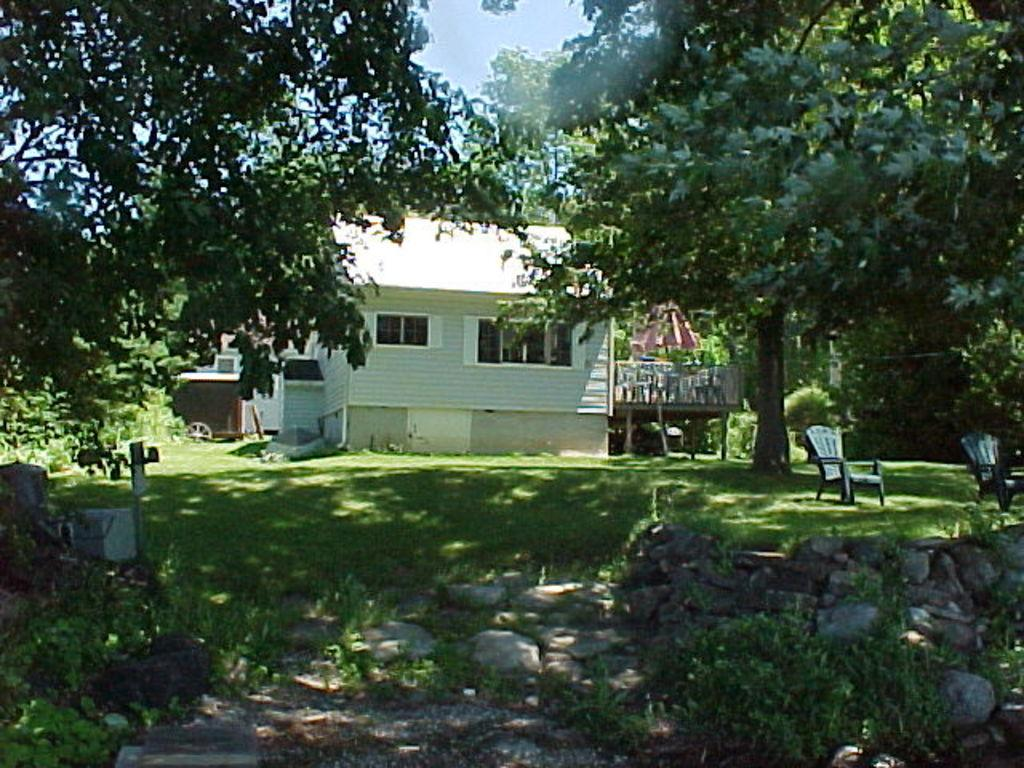What type of surface is visible in the image? There is a grass surface in the image. What type of vegetation is present in the image? There are trees in the image. What type of furniture is visible in the image? There are chairs in the image. What type of structure is present in the image? There is a house in the image. What is visible in the background of the image? The sky is visible in the image. What time of day is it in the image, based on the presence of ants? There are no ants present in the image, so we cannot determine the time of day based on their presence. 